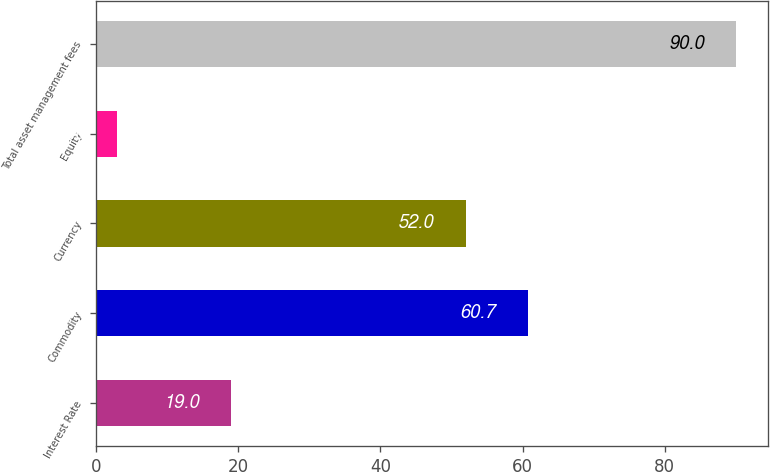Convert chart to OTSL. <chart><loc_0><loc_0><loc_500><loc_500><bar_chart><fcel>Interest Rate<fcel>Commodity<fcel>Currency<fcel>Equity<fcel>Total asset management fees<nl><fcel>19<fcel>60.7<fcel>52<fcel>3<fcel>90<nl></chart> 